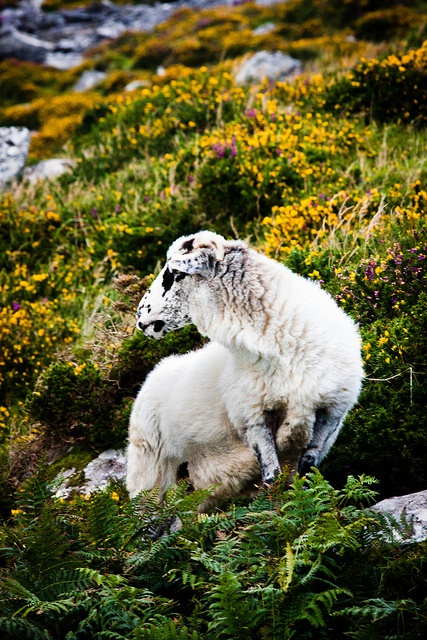Describe the objects in this image and their specific colors. I can see a sheep in black, lightgray, darkgray, and gray tones in this image. 